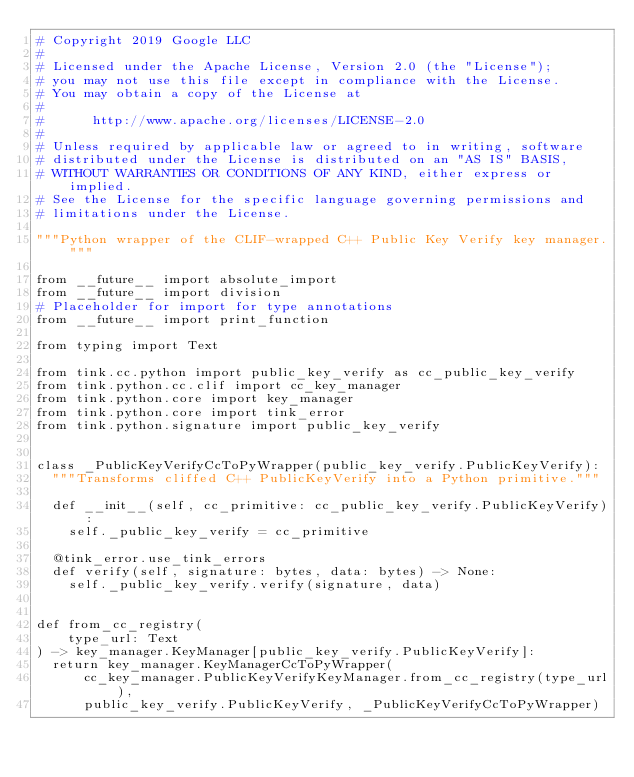<code> <loc_0><loc_0><loc_500><loc_500><_Python_># Copyright 2019 Google LLC
#
# Licensed under the Apache License, Version 2.0 (the "License");
# you may not use this file except in compliance with the License.
# You may obtain a copy of the License at
#
#      http://www.apache.org/licenses/LICENSE-2.0
#
# Unless required by applicable law or agreed to in writing, software
# distributed under the License is distributed on an "AS IS" BASIS,
# WITHOUT WARRANTIES OR CONDITIONS OF ANY KIND, either express or implied.
# See the License for the specific language governing permissions and
# limitations under the License.

"""Python wrapper of the CLIF-wrapped C++ Public Key Verify key manager."""

from __future__ import absolute_import
from __future__ import division
# Placeholder for import for type annotations
from __future__ import print_function

from typing import Text

from tink.cc.python import public_key_verify as cc_public_key_verify
from tink.python.cc.clif import cc_key_manager
from tink.python.core import key_manager
from tink.python.core import tink_error
from tink.python.signature import public_key_verify


class _PublicKeyVerifyCcToPyWrapper(public_key_verify.PublicKeyVerify):
  """Transforms cliffed C++ PublicKeyVerify into a Python primitive."""

  def __init__(self, cc_primitive: cc_public_key_verify.PublicKeyVerify):
    self._public_key_verify = cc_primitive

  @tink_error.use_tink_errors
  def verify(self, signature: bytes, data: bytes) -> None:
    self._public_key_verify.verify(signature, data)


def from_cc_registry(
    type_url: Text
) -> key_manager.KeyManager[public_key_verify.PublicKeyVerify]:
  return key_manager.KeyManagerCcToPyWrapper(
      cc_key_manager.PublicKeyVerifyKeyManager.from_cc_registry(type_url),
      public_key_verify.PublicKeyVerify, _PublicKeyVerifyCcToPyWrapper)
</code> 